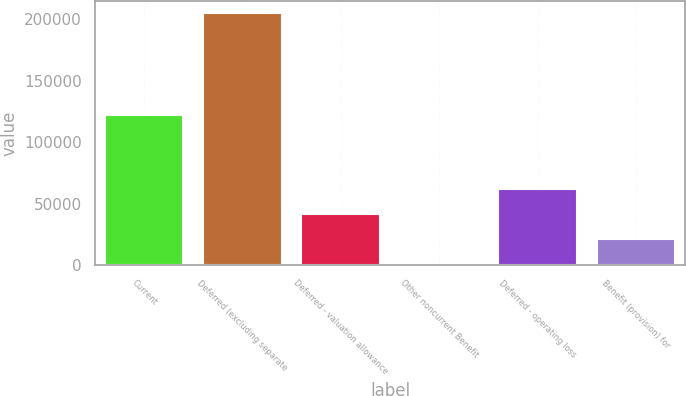<chart> <loc_0><loc_0><loc_500><loc_500><bar_chart><fcel>Current<fcel>Deferred (excluding separate<fcel>Deferred - valuation allowance<fcel>Other noncurrent Benefit<fcel>Deferred - operating loss<fcel>Benefit (provision) for<nl><fcel>121779<fcel>204713<fcel>42027.4<fcel>1356<fcel>62363.1<fcel>21691.7<nl></chart> 